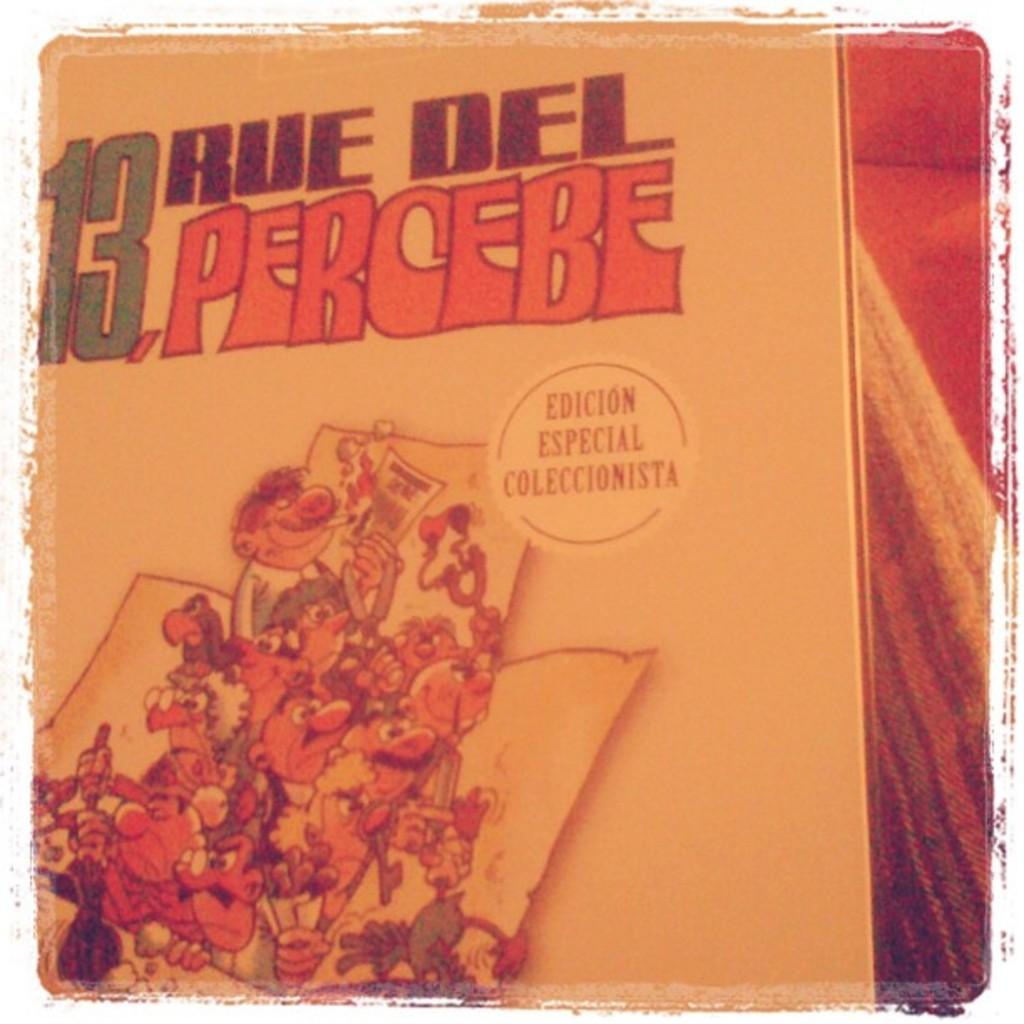Provide a one-sentence caption for the provided image. 13 rue del percebe edicion especial coleccionista wrote in spanish on a book. 